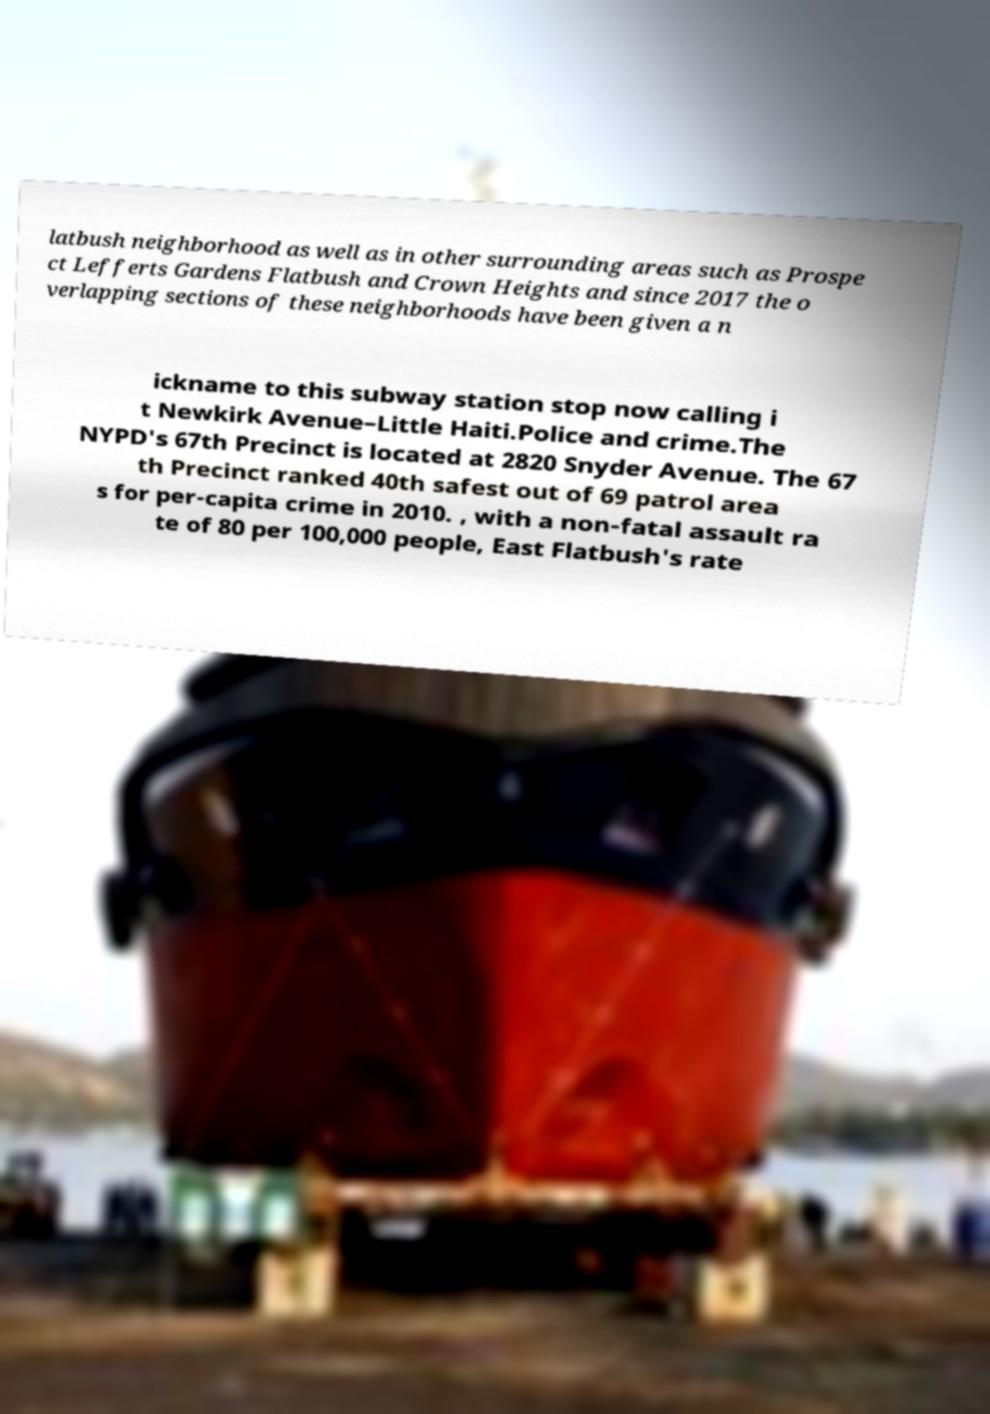There's text embedded in this image that I need extracted. Can you transcribe it verbatim? latbush neighborhood as well as in other surrounding areas such as Prospe ct Lefferts Gardens Flatbush and Crown Heights and since 2017 the o verlapping sections of these neighborhoods have been given a n ickname to this subway station stop now calling i t Newkirk Avenue–Little Haiti.Police and crime.The NYPD's 67th Precinct is located at 2820 Snyder Avenue. The 67 th Precinct ranked 40th safest out of 69 patrol area s for per-capita crime in 2010. , with a non-fatal assault ra te of 80 per 100,000 people, East Flatbush's rate 